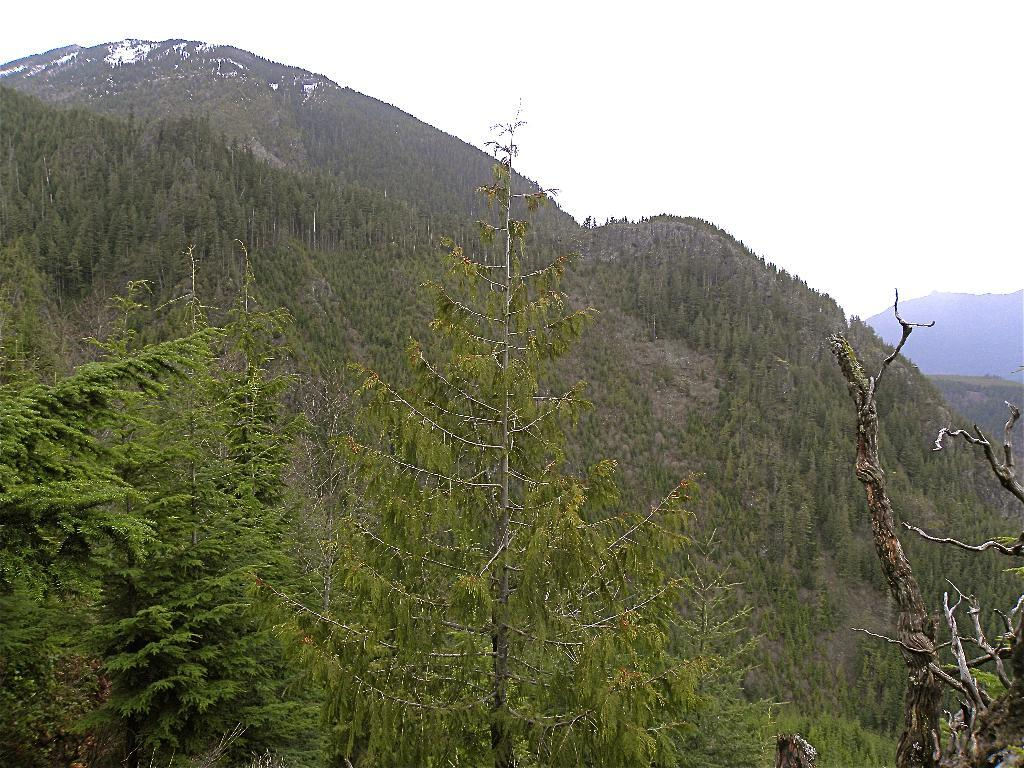What type of vegetation can be seen in the image? There are trees in the image. What can be seen in the background of the image? There are hills visible in the background of the image. What part of the natural environment is visible in the image? The sky is visible in the background of the image. What type of riddle can be seen written on the guitar in the image? There is no guitar present in the image, so it is not possible to answer that question. 